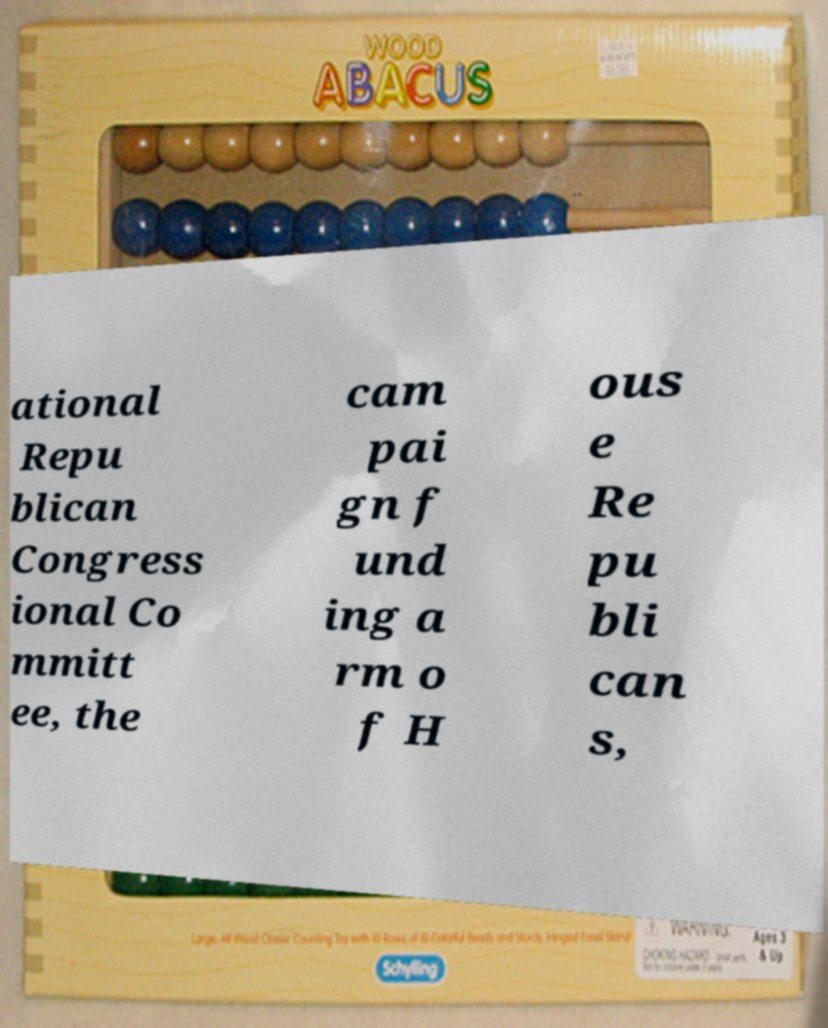Could you assist in decoding the text presented in this image and type it out clearly? ational Repu blican Congress ional Co mmitt ee, the cam pai gn f und ing a rm o f H ous e Re pu bli can s, 